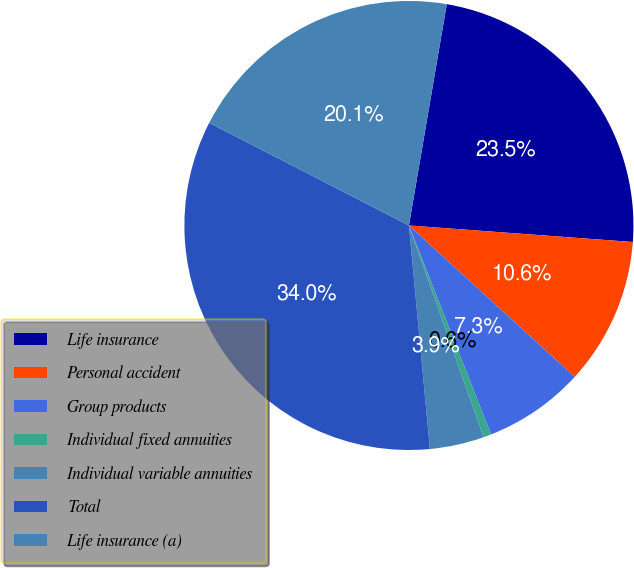Convert chart to OTSL. <chart><loc_0><loc_0><loc_500><loc_500><pie_chart><fcel>Life insurance<fcel>Personal accident<fcel>Group products<fcel>Individual fixed annuities<fcel>Individual variable annuities<fcel>Total<fcel>Life insurance (a)<nl><fcel>23.48%<fcel>10.61%<fcel>7.26%<fcel>0.56%<fcel>3.91%<fcel>34.05%<fcel>20.14%<nl></chart> 